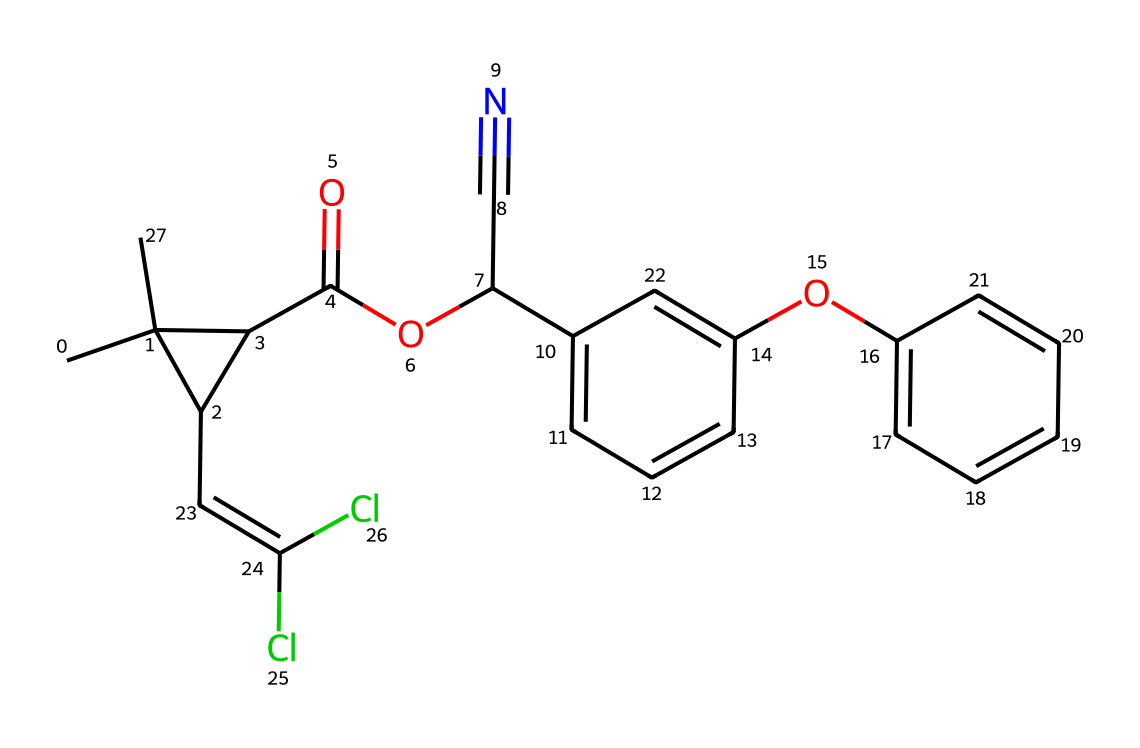What is the main functional group present in this compound? The compound contains an ester functional group indicated by the carbonyl (C=O) adjacent to an oxygen (O). This is typically characterized in the structure by the presence of -COOR.
Answer: ester How many rings are present in the structure? The chemical structure shows two distinct aromatic rings, which can be identified by the connected cyclical carbon frameworks in the SMILES notation. Counting these leads us to confirm the presence of two rings.
Answer: 2 What type of pesticide does this compound belong to? This compound is classified as a pyrethroid, which is a synthetic variant of natural pyrethrins used in pesticides based on its structure and functional groups tailored for insecticidal activity.
Answer: pyrethroid How many aromatic rings are fused with the main structure? The structure includes two aromatic rings. We can identify these by looking for resonance-stabilized cyclic arrangements of alternating double bonds, indicating the presence of fused aromatic systems.
Answer: 2 What is the effect of the chlorine substituents in this compound? The chlorine substituents on the alkene part of the structure enhance the insecticidal properties by increasing the molecule's lipophilicity, thereby improving its penetration through the insect's exoskeleton and increasing toxicity.
Answer: toxicity What element is represented by the ‘N’ in the structure and what is its role? The ‘N’ in the SMILES indicates the presence of a cyano (-C≡N) group, which is often used to enhance pesticides' potency by affecting the nervous system of the target insect.
Answer: cyano 